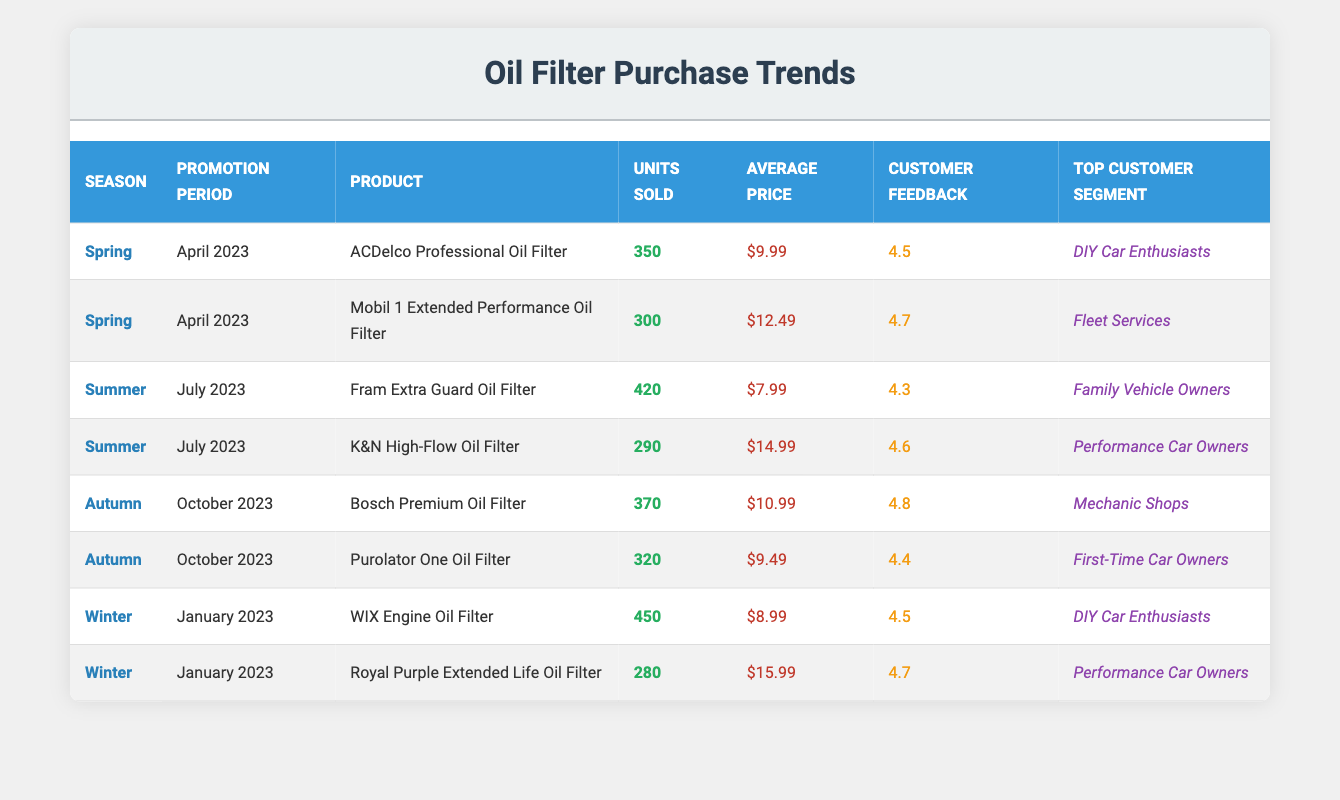What oil filter had the highest units sold during the Summer promotion period? The table shows that during the Summer promotion period in July 2023, the Fram Extra Guard Oil Filter had the highest units sold with 420.
Answer: Fram Extra Guard Oil Filter Which season had the lowest customer feedback score average? The average feedback score can be calculated for each season: Spring ((4.5 + 4.7)/2 = 4.6), Summer ((4.3 + 4.6)/2 = 4.45), Autumn ((4.8 + 4.4)/2 = 4.6), Winter ((4.5 + 4.7)/2 = 4.6). The lowest average is in Summer, which is 4.45.
Answer: Summer Did the ACDelco Professional Oil Filter sell more units than the Royal Purple Extended Life Oil Filter? ACDelco Professional Oil Filter sold 350 units while Royal Purple Extended Life Oil Filter sold 280 units. Since 350 is greater than 280, the statement is true.
Answer: Yes What is the total number of units sold across all promotion periods for oil filters? To find the total, add the units sold: 350 + 300 + 420 + 290 + 370 + 320 + 450 + 280 = 2,680 units sold in total.
Answer: 2,680 Which product had the highest average price and what was that price? The product with the highest average price was Royal Purple Extended Life Oil Filter at $15.99. This can be verified by looking at the average prices in the table.
Answer: Royal Purple Extended Life Oil Filter, $15.99 What is the percentage of units sold by DIY Car Enthusiasts for the Winter promotion period? DIY Car Enthusiasts purchased WIX Engine Oil Filter (450 units) during Winter. Total units sold in Winter (450 + 280) = 730. The percentage is (450/730) * 100 ≈ 61.64%.
Answer: ≈ 61.64% Are there any products that sold more than 300 units in the Autumn promotion period? In Autumn, the Bosch Premium Oil Filter (370 units) and Purolator One Oil Filter (320 units) both sold more than 300 units, making this statement true.
Answer: Yes What is the average customer feedback score for all products sold? To calculate the average feedback score, sum all scores (4.5 + 4.7 + 4.3 + 4.6 + 4.8 + 4.4 + 4.5 + 4.7 = 36.5) and divide by the number of products, which is 8: 36.5 / 8 = 4.56.
Answer: 4.56 